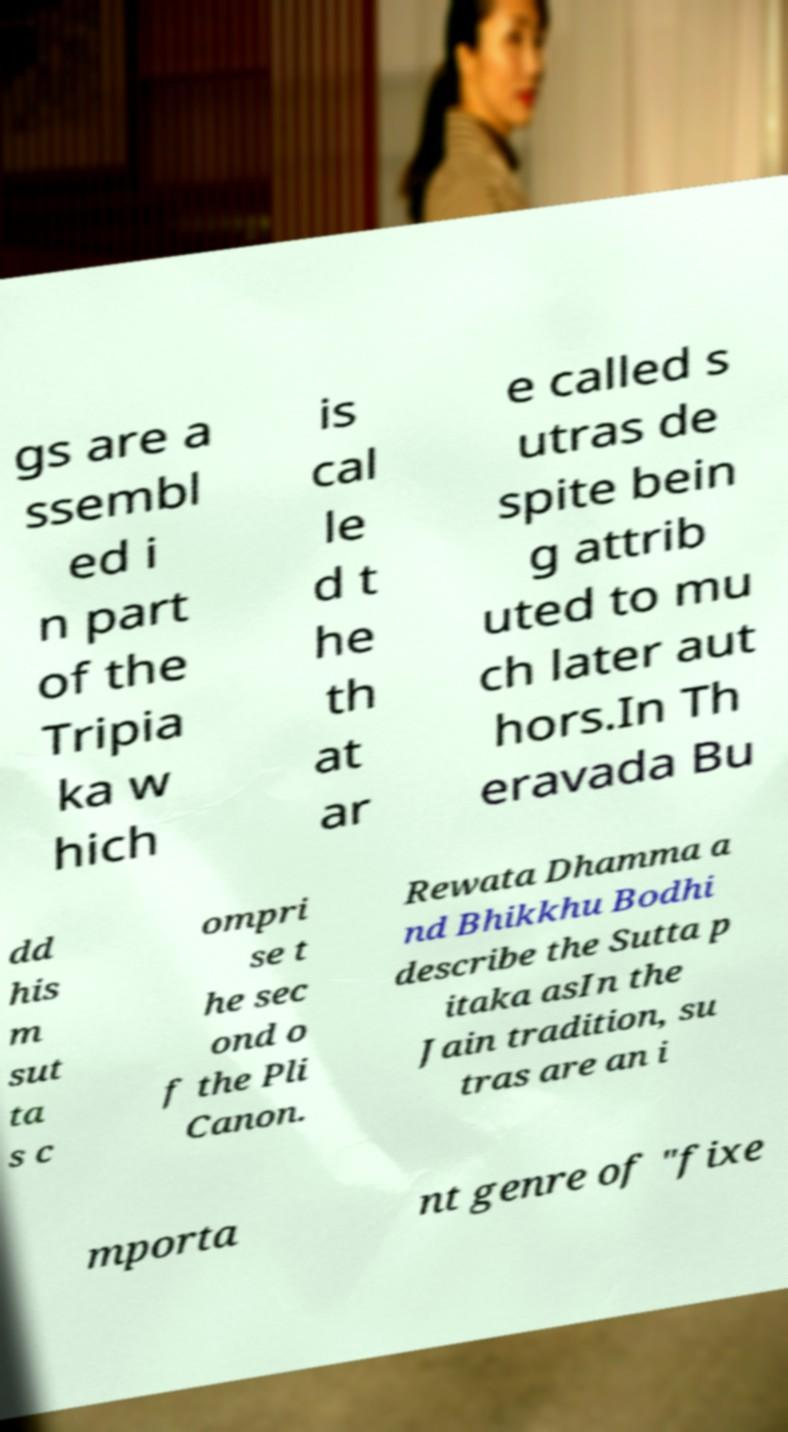For documentation purposes, I need the text within this image transcribed. Could you provide that? gs are a ssembl ed i n part of the Tripia ka w hich is cal le d t he th at ar e called s utras de spite bein g attrib uted to mu ch later aut hors.In Th eravada Bu dd his m sut ta s c ompri se t he sec ond o f the Pli Canon. Rewata Dhamma a nd Bhikkhu Bodhi describe the Sutta p itaka asIn the Jain tradition, su tras are an i mporta nt genre of "fixe 